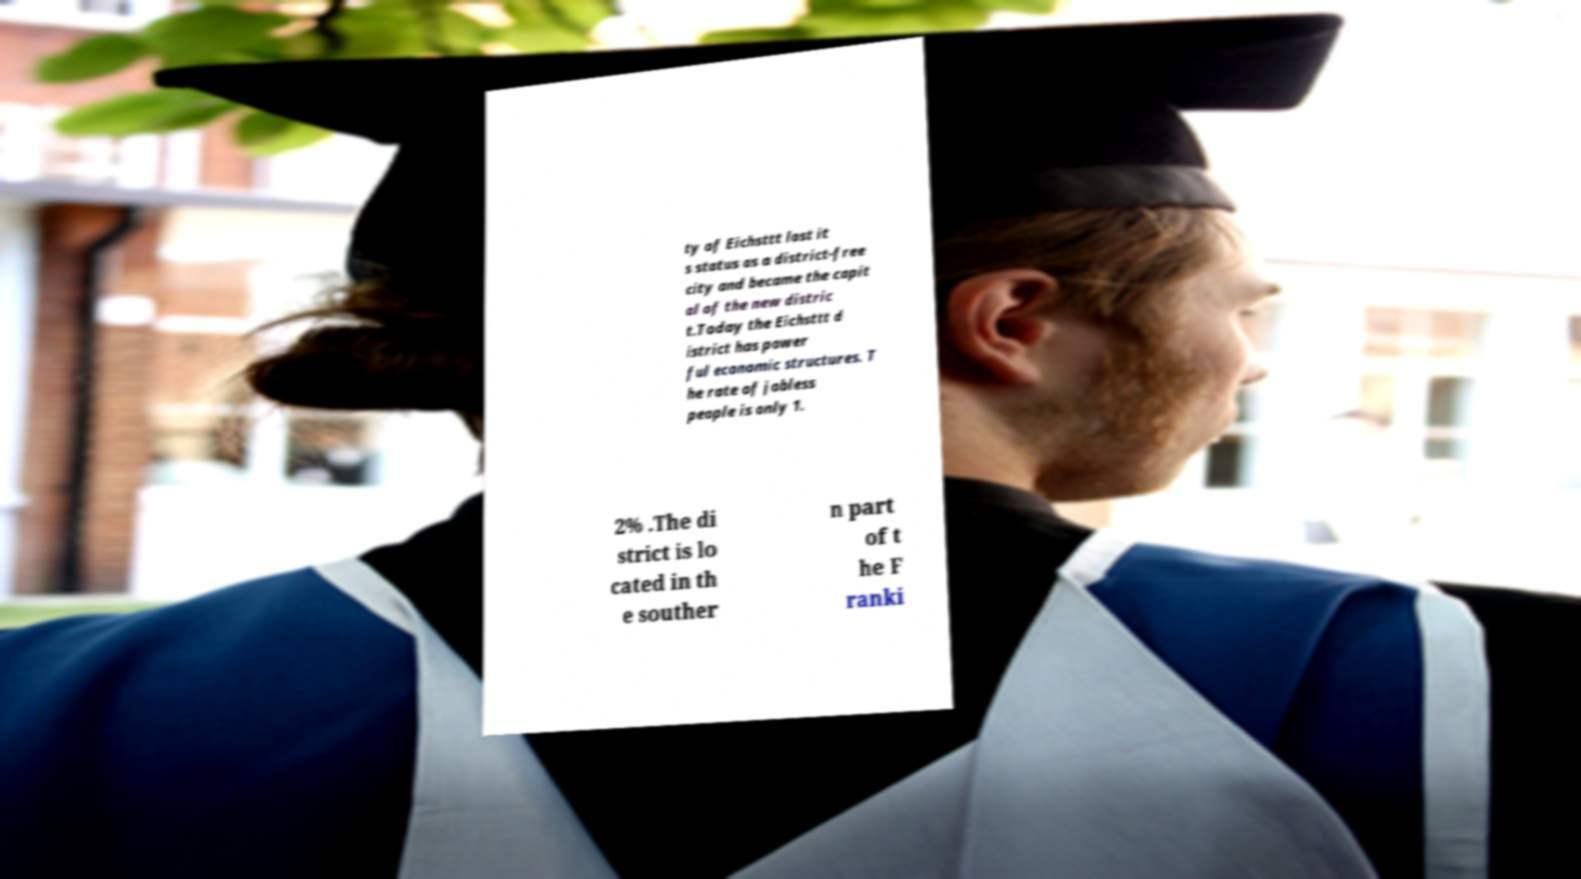Could you assist in decoding the text presented in this image and type it out clearly? ty of Eichsttt lost it s status as a district-free city and became the capit al of the new distric t.Today the Eichsttt d istrict has power ful economic structures. T he rate of jobless people is only 1. 2% .The di strict is lo cated in th e souther n part of t he F ranki 